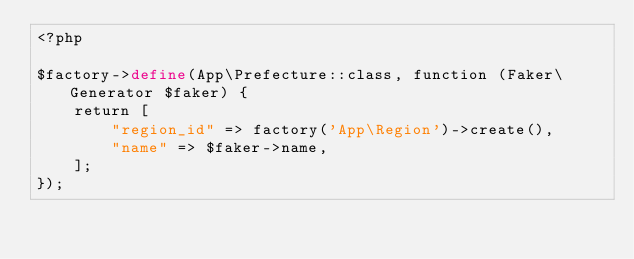<code> <loc_0><loc_0><loc_500><loc_500><_PHP_><?php

$factory->define(App\Prefecture::class, function (Faker\Generator $faker) {
    return [
        "region_id" => factory('App\Region')->create(),
        "name" => $faker->name,
    ];
});
</code> 